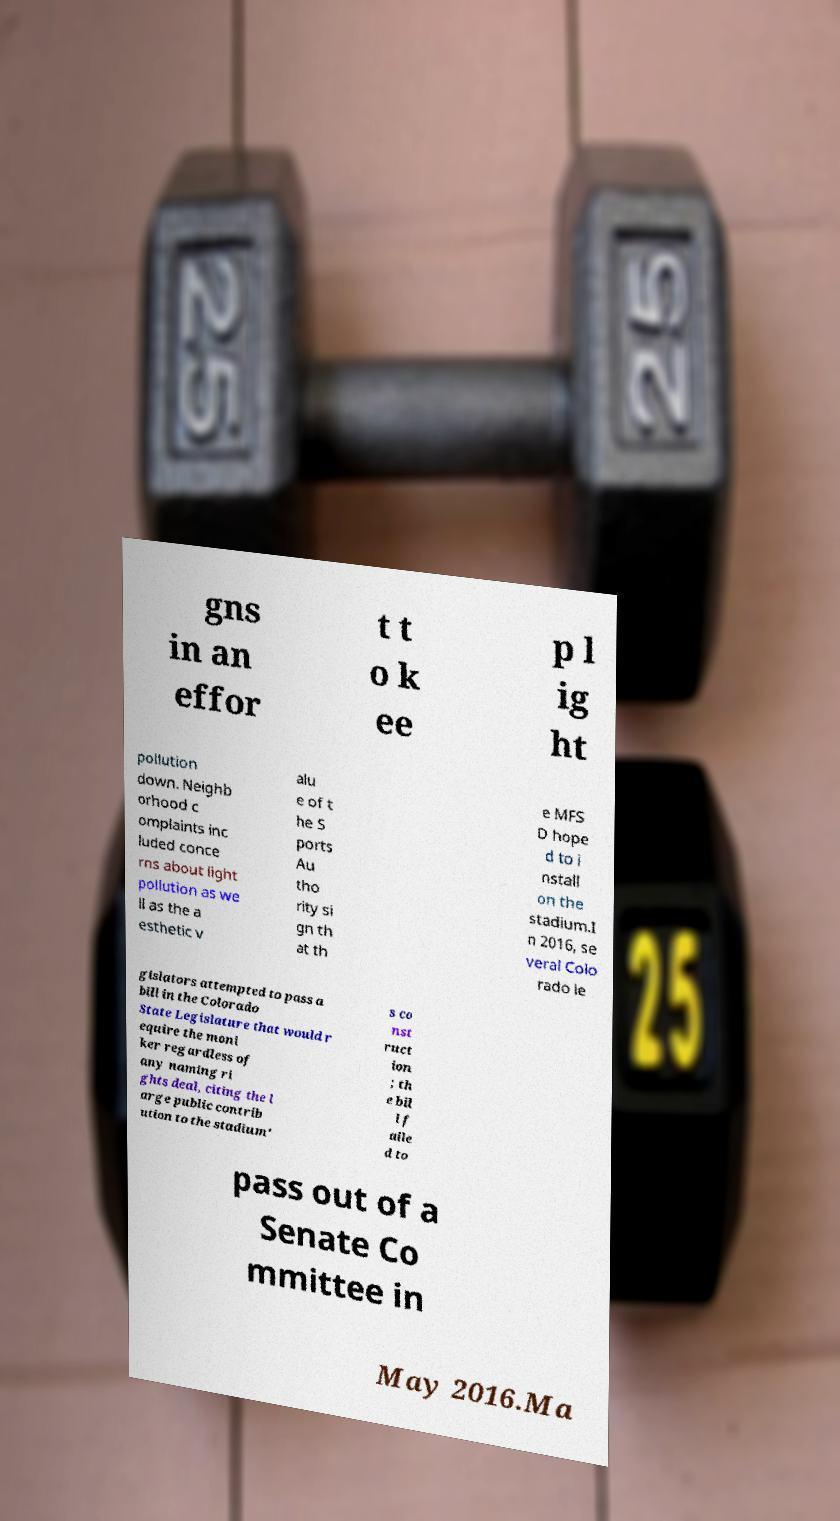Please identify and transcribe the text found in this image. gns in an effor t t o k ee p l ig ht pollution down. Neighb orhood c omplaints inc luded conce rns about light pollution as we ll as the a esthetic v alu e of t he S ports Au tho rity si gn th at th e MFS D hope d to i nstall on the stadium.I n 2016, se veral Colo rado le gislators attempted to pass a bill in the Colorado State Legislature that would r equire the moni ker regardless of any naming ri ghts deal, citing the l arge public contrib ution to the stadium' s co nst ruct ion ; th e bil l f aile d to pass out of a Senate Co mmittee in May 2016.Ma 